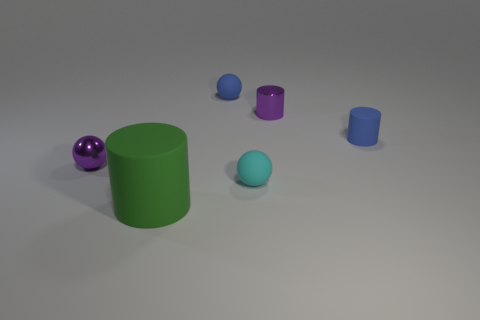Is there anything else that has the same size as the green matte cylinder?
Offer a very short reply. No. There is a thing that is the same color as the small metal cylinder; what material is it?
Ensure brevity in your answer.  Metal. Does the blue matte cylinder have the same size as the purple metallic ball?
Your response must be concise. Yes. How big is the cylinder that is on the right side of the big object and in front of the purple cylinder?
Ensure brevity in your answer.  Small. How many shiny things are small blue cylinders or green things?
Make the answer very short. 0. Is the number of blue rubber things behind the tiny blue cylinder greater than the number of yellow rubber balls?
Your answer should be very brief. Yes. What is the material of the small purple thing to the left of the green cylinder?
Your answer should be very brief. Metal. What number of small things have the same material as the blue ball?
Make the answer very short. 2. There is a matte thing that is to the right of the green rubber cylinder and to the left of the cyan object; what shape is it?
Your answer should be very brief. Sphere. How many things are either large green rubber cylinders to the right of the purple ball or metallic objects left of the big green object?
Your answer should be compact. 2. 